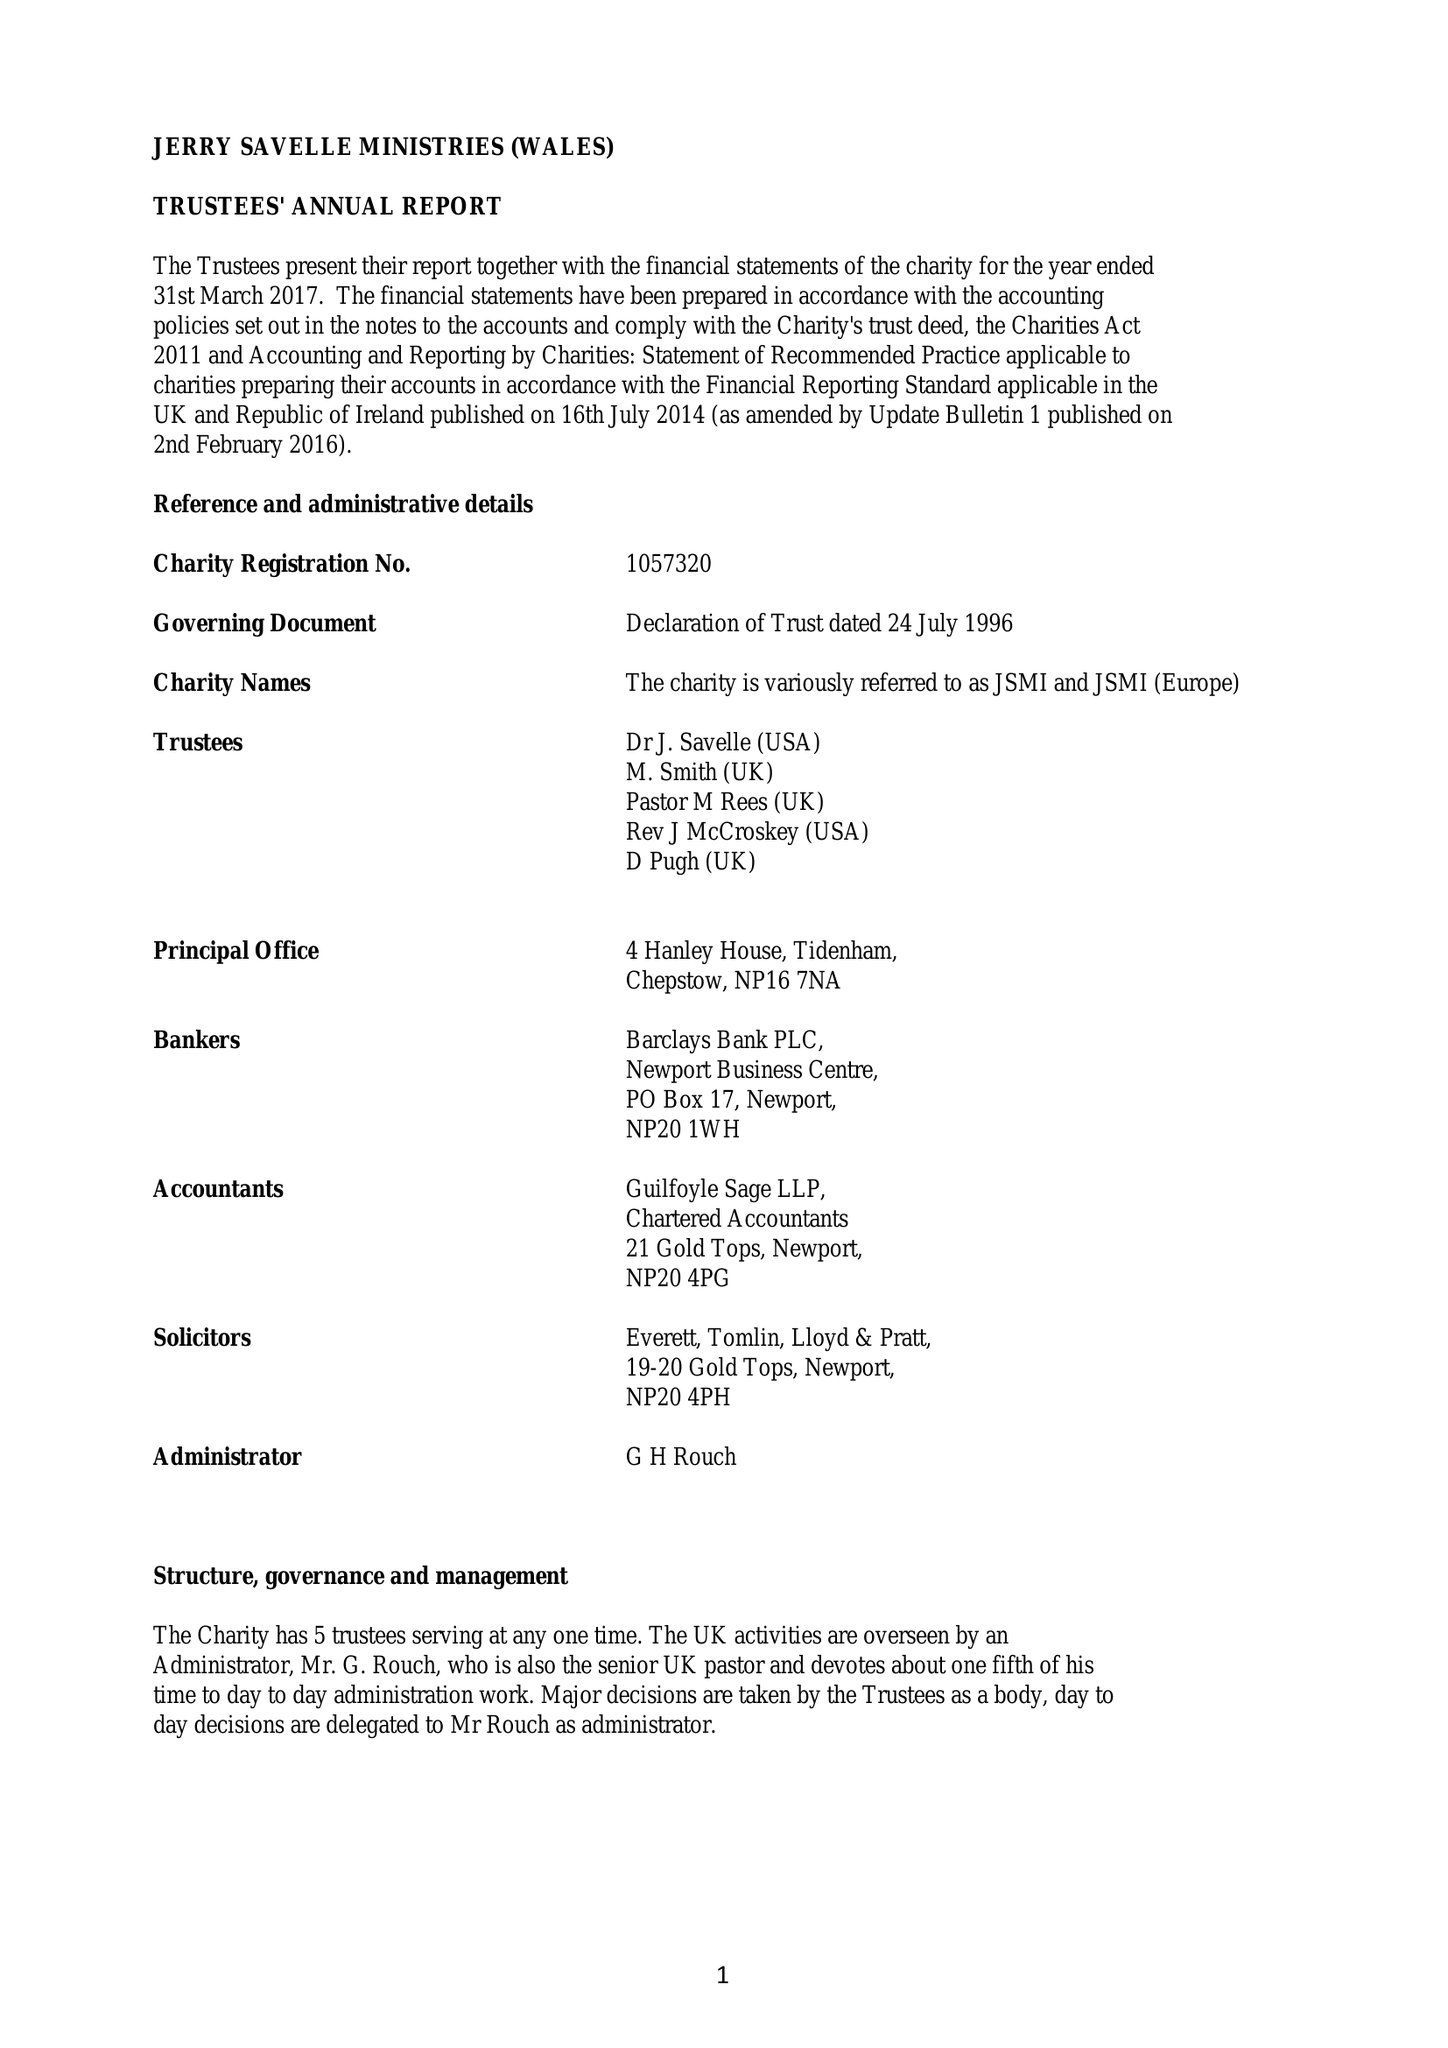What is the value for the address__post_town?
Answer the question using a single word or phrase. CHEPSTOW 